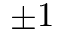<formula> <loc_0><loc_0><loc_500><loc_500>\pm 1</formula> 